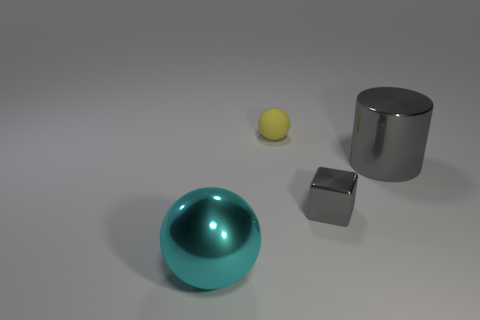What size is the metal block that is the same color as the cylinder?
Your answer should be compact. Small. There is a gray shiny cylinder; are there any gray objects in front of it?
Keep it short and to the point. Yes. How many metallic blocks are to the left of the big metallic ball in front of the large gray metallic thing?
Keep it short and to the point. 0. Do the block and the object that is to the left of the small sphere have the same size?
Keep it short and to the point. No. Are there any big metal cylinders that have the same color as the rubber ball?
Provide a succinct answer. No. What size is the cyan sphere that is made of the same material as the gray cube?
Your response must be concise. Large. Is the small gray thing made of the same material as the cyan object?
Offer a terse response. Yes. What is the color of the big shiny object that is behind the tiny object right of the tiny thing behind the gray metallic cylinder?
Give a very brief answer. Gray. There is a yellow object; what shape is it?
Offer a terse response. Sphere. There is a metallic sphere; is its color the same as the ball behind the small gray metal block?
Make the answer very short. No. 